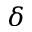<formula> <loc_0><loc_0><loc_500><loc_500>\delta</formula> 